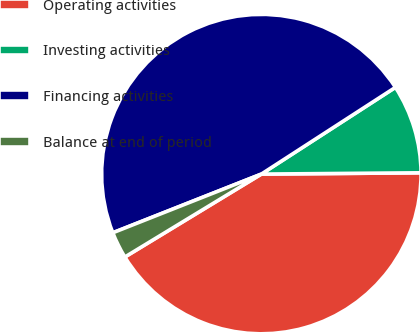<chart> <loc_0><loc_0><loc_500><loc_500><pie_chart><fcel>Operating activities<fcel>Investing activities<fcel>Financing activities<fcel>Balance at end of period<nl><fcel>41.44%<fcel>9.01%<fcel>46.85%<fcel>2.7%<nl></chart> 